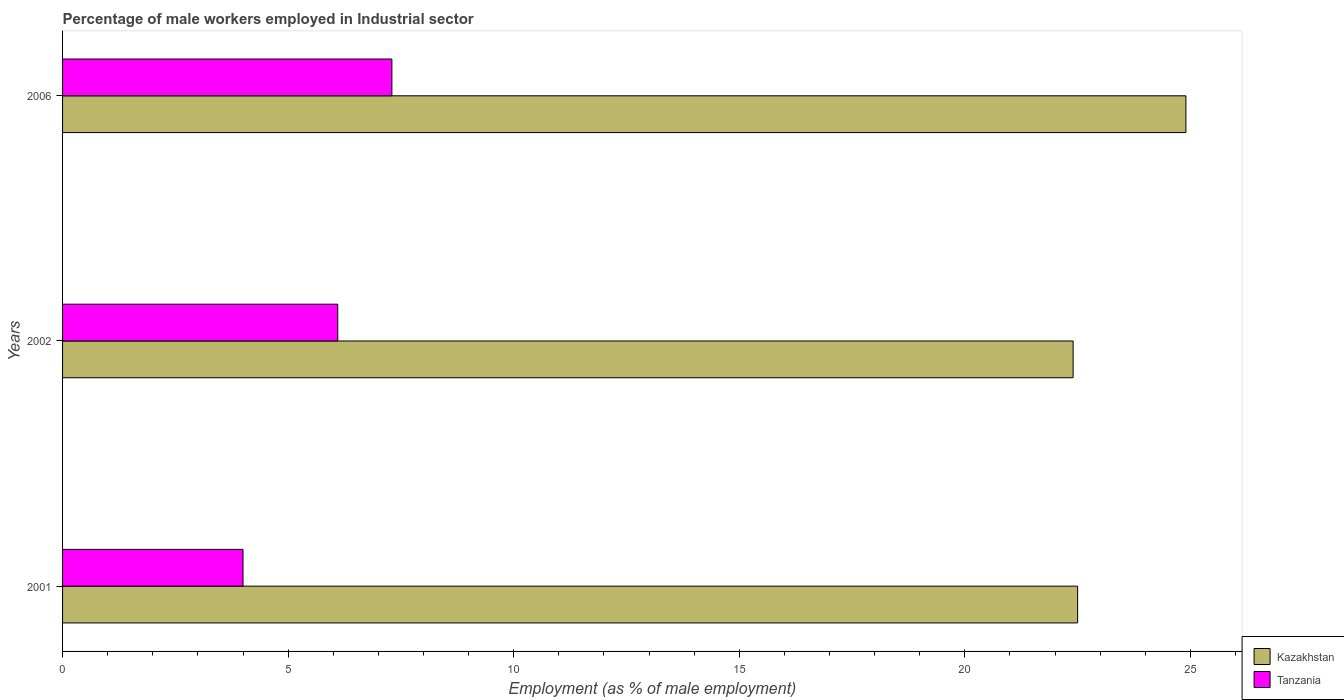How many different coloured bars are there?
Give a very brief answer. 2. How many groups of bars are there?
Your answer should be very brief. 3. How many bars are there on the 3rd tick from the top?
Your answer should be very brief. 2. In how many cases, is the number of bars for a given year not equal to the number of legend labels?
Provide a short and direct response. 0. What is the percentage of male workers employed in Industrial sector in Tanzania in 2002?
Your answer should be compact. 6.1. Across all years, what is the maximum percentage of male workers employed in Industrial sector in Tanzania?
Your response must be concise. 7.3. Across all years, what is the minimum percentage of male workers employed in Industrial sector in Kazakhstan?
Your answer should be very brief. 22.4. In which year was the percentage of male workers employed in Industrial sector in Kazakhstan maximum?
Ensure brevity in your answer.  2006. What is the total percentage of male workers employed in Industrial sector in Kazakhstan in the graph?
Your answer should be compact. 69.8. What is the difference between the percentage of male workers employed in Industrial sector in Tanzania in 2002 and that in 2006?
Provide a succinct answer. -1.2. What is the difference between the percentage of male workers employed in Industrial sector in Tanzania in 2006 and the percentage of male workers employed in Industrial sector in Kazakhstan in 2002?
Your response must be concise. -15.1. What is the average percentage of male workers employed in Industrial sector in Kazakhstan per year?
Offer a terse response. 23.27. In the year 2006, what is the difference between the percentage of male workers employed in Industrial sector in Tanzania and percentage of male workers employed in Industrial sector in Kazakhstan?
Provide a succinct answer. -17.6. What is the ratio of the percentage of male workers employed in Industrial sector in Kazakhstan in 2002 to that in 2006?
Your answer should be very brief. 0.9. What is the difference between the highest and the second highest percentage of male workers employed in Industrial sector in Kazakhstan?
Ensure brevity in your answer.  2.4. What is the difference between the highest and the lowest percentage of male workers employed in Industrial sector in Tanzania?
Your answer should be very brief. 3.3. In how many years, is the percentage of male workers employed in Industrial sector in Tanzania greater than the average percentage of male workers employed in Industrial sector in Tanzania taken over all years?
Your answer should be compact. 2. What does the 2nd bar from the top in 2002 represents?
Offer a terse response. Kazakhstan. What does the 1st bar from the bottom in 2006 represents?
Your answer should be very brief. Kazakhstan. Are all the bars in the graph horizontal?
Your answer should be very brief. Yes. How many years are there in the graph?
Give a very brief answer. 3. What is the difference between two consecutive major ticks on the X-axis?
Offer a terse response. 5. Does the graph contain any zero values?
Give a very brief answer. No. Where does the legend appear in the graph?
Ensure brevity in your answer.  Bottom right. How are the legend labels stacked?
Provide a succinct answer. Vertical. What is the title of the graph?
Give a very brief answer. Percentage of male workers employed in Industrial sector. What is the label or title of the X-axis?
Keep it short and to the point. Employment (as % of male employment). What is the Employment (as % of male employment) in Kazakhstan in 2001?
Make the answer very short. 22.5. What is the Employment (as % of male employment) of Kazakhstan in 2002?
Give a very brief answer. 22.4. What is the Employment (as % of male employment) in Tanzania in 2002?
Provide a succinct answer. 6.1. What is the Employment (as % of male employment) of Kazakhstan in 2006?
Your answer should be compact. 24.9. What is the Employment (as % of male employment) of Tanzania in 2006?
Provide a succinct answer. 7.3. Across all years, what is the maximum Employment (as % of male employment) in Kazakhstan?
Your response must be concise. 24.9. Across all years, what is the maximum Employment (as % of male employment) in Tanzania?
Offer a very short reply. 7.3. Across all years, what is the minimum Employment (as % of male employment) of Kazakhstan?
Your answer should be compact. 22.4. What is the total Employment (as % of male employment) in Kazakhstan in the graph?
Offer a terse response. 69.8. What is the total Employment (as % of male employment) in Tanzania in the graph?
Your answer should be very brief. 17.4. What is the difference between the Employment (as % of male employment) of Tanzania in 2001 and that in 2002?
Provide a succinct answer. -2.1. What is the difference between the Employment (as % of male employment) of Kazakhstan in 2001 and that in 2006?
Offer a very short reply. -2.4. What is the difference between the Employment (as % of male employment) of Kazakhstan in 2002 and the Employment (as % of male employment) of Tanzania in 2006?
Offer a very short reply. 15.1. What is the average Employment (as % of male employment) of Kazakhstan per year?
Ensure brevity in your answer.  23.27. What is the average Employment (as % of male employment) of Tanzania per year?
Offer a very short reply. 5.8. In the year 2001, what is the difference between the Employment (as % of male employment) of Kazakhstan and Employment (as % of male employment) of Tanzania?
Your answer should be compact. 18.5. What is the ratio of the Employment (as % of male employment) of Kazakhstan in 2001 to that in 2002?
Provide a succinct answer. 1. What is the ratio of the Employment (as % of male employment) of Tanzania in 2001 to that in 2002?
Make the answer very short. 0.66. What is the ratio of the Employment (as % of male employment) in Kazakhstan in 2001 to that in 2006?
Your answer should be very brief. 0.9. What is the ratio of the Employment (as % of male employment) in Tanzania in 2001 to that in 2006?
Your answer should be very brief. 0.55. What is the ratio of the Employment (as % of male employment) in Kazakhstan in 2002 to that in 2006?
Provide a succinct answer. 0.9. What is the ratio of the Employment (as % of male employment) in Tanzania in 2002 to that in 2006?
Give a very brief answer. 0.84. What is the difference between the highest and the second highest Employment (as % of male employment) of Kazakhstan?
Provide a succinct answer. 2.4. What is the difference between the highest and the second highest Employment (as % of male employment) of Tanzania?
Offer a terse response. 1.2. What is the difference between the highest and the lowest Employment (as % of male employment) of Tanzania?
Provide a succinct answer. 3.3. 